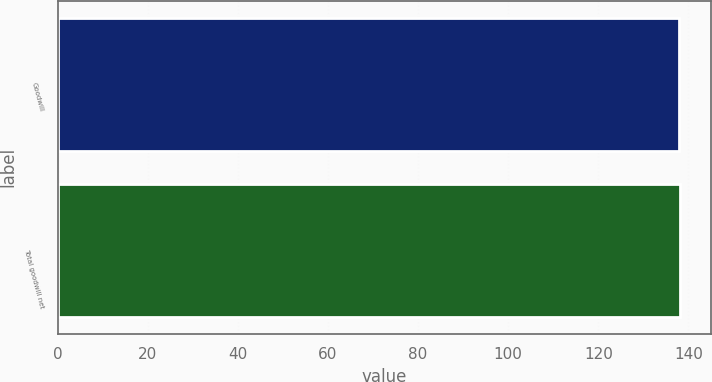Convert chart. <chart><loc_0><loc_0><loc_500><loc_500><bar_chart><fcel>Goodwill<fcel>Total goodwill net<nl><fcel>138<fcel>138.1<nl></chart> 